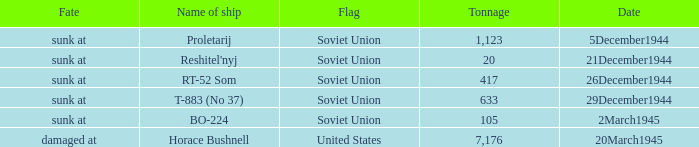What is the average tonnage of the ship named proletarij? 1123.0. 